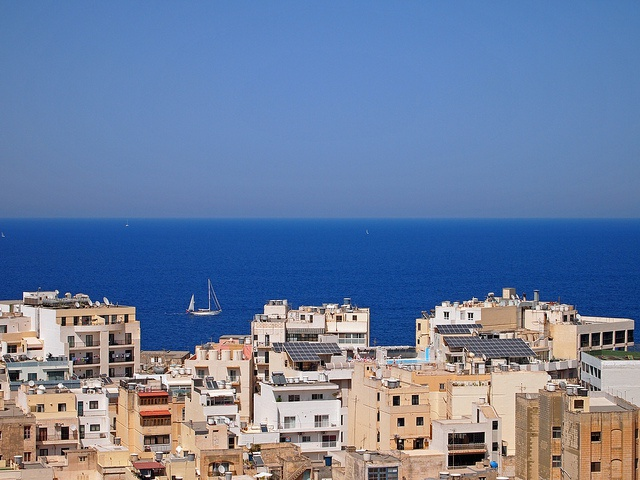Describe the objects in this image and their specific colors. I can see boat in gray, darkgray, navy, and blue tones, boat in blue and gray tones, and boat in gray, blue, and darkgray tones in this image. 